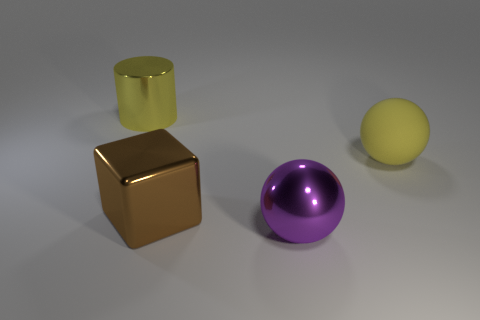Imagine this is a scene from a story. What could be happening here? This scene could depict a moment of tranquility on a distant planet, where these vibrant objects are artifacts of an advanced, peaceful civilization, possibly serving a symbolic or functional purpose. 